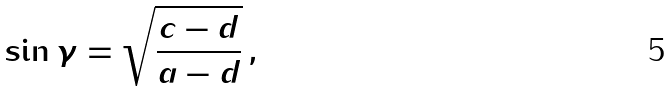Convert formula to latex. <formula><loc_0><loc_0><loc_500><loc_500>\sin \gamma = \sqrt { \frac { c - d } { a - d } } \, ,</formula> 